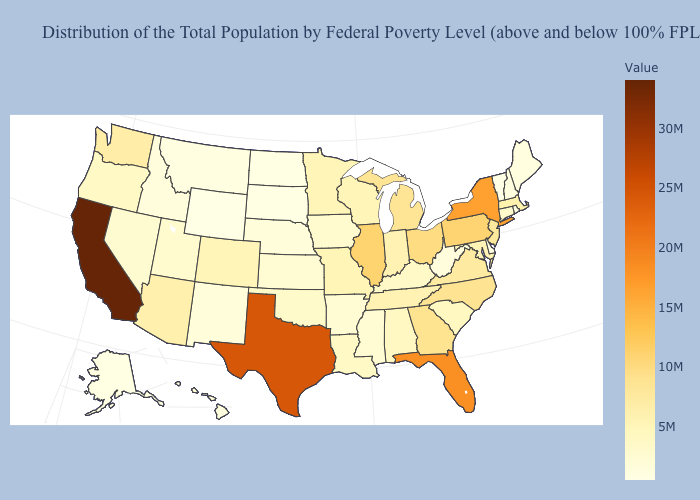Does Wyoming have the lowest value in the West?
Keep it brief. Yes. Does Minnesota have a lower value than Hawaii?
Write a very short answer. No. Does Ohio have the highest value in the USA?
Give a very brief answer. No. Does South Carolina have the highest value in the South?
Keep it brief. No. Does Utah have a higher value than Florida?
Give a very brief answer. No. Among the states that border Michigan , does Wisconsin have the lowest value?
Answer briefly. Yes. 